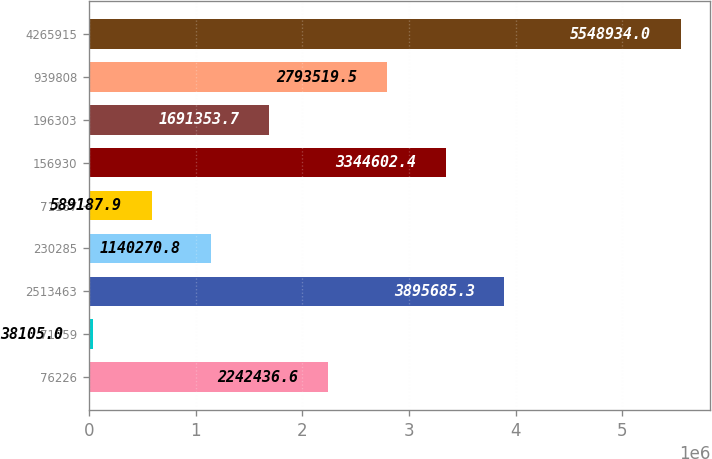Convert chart to OTSL. <chart><loc_0><loc_0><loc_500><loc_500><bar_chart><fcel>76226<fcel>71559<fcel>2513463<fcel>230285<fcel>71167<fcel>156930<fcel>196303<fcel>939808<fcel>4265915<nl><fcel>2.24244e+06<fcel>38105<fcel>3.89569e+06<fcel>1.14027e+06<fcel>589188<fcel>3.3446e+06<fcel>1.69135e+06<fcel>2.79352e+06<fcel>5.54893e+06<nl></chart> 